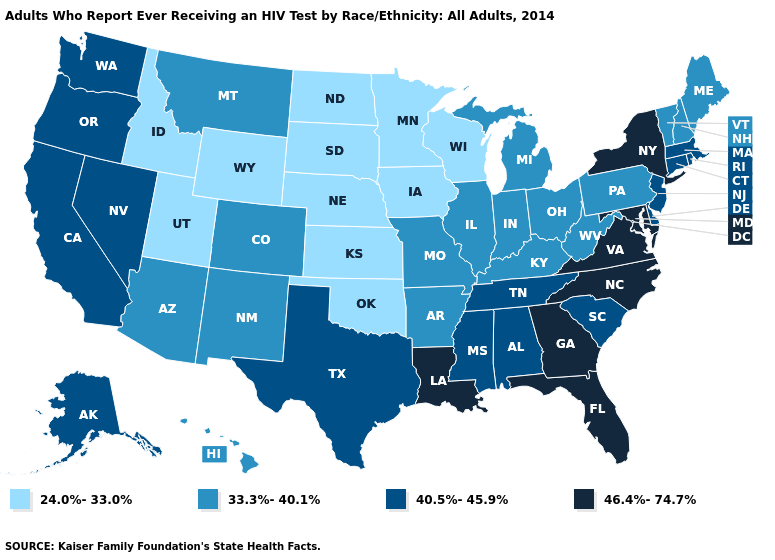Is the legend a continuous bar?
Short answer required. No. What is the lowest value in the USA?
Give a very brief answer. 24.0%-33.0%. Does the map have missing data?
Give a very brief answer. No. Name the states that have a value in the range 46.4%-74.7%?
Give a very brief answer. Florida, Georgia, Louisiana, Maryland, New York, North Carolina, Virginia. Among the states that border Wyoming , which have the lowest value?
Short answer required. Idaho, Nebraska, South Dakota, Utah. Name the states that have a value in the range 40.5%-45.9%?
Short answer required. Alabama, Alaska, California, Connecticut, Delaware, Massachusetts, Mississippi, Nevada, New Jersey, Oregon, Rhode Island, South Carolina, Tennessee, Texas, Washington. What is the lowest value in the Northeast?
Answer briefly. 33.3%-40.1%. Does the first symbol in the legend represent the smallest category?
Give a very brief answer. Yes. Does the first symbol in the legend represent the smallest category?
Short answer required. Yes. Is the legend a continuous bar?
Answer briefly. No. What is the value of Washington?
Answer briefly. 40.5%-45.9%. Does South Dakota have the same value as Iowa?
Give a very brief answer. Yes. Does West Virginia have the same value as Indiana?
Be succinct. Yes. 